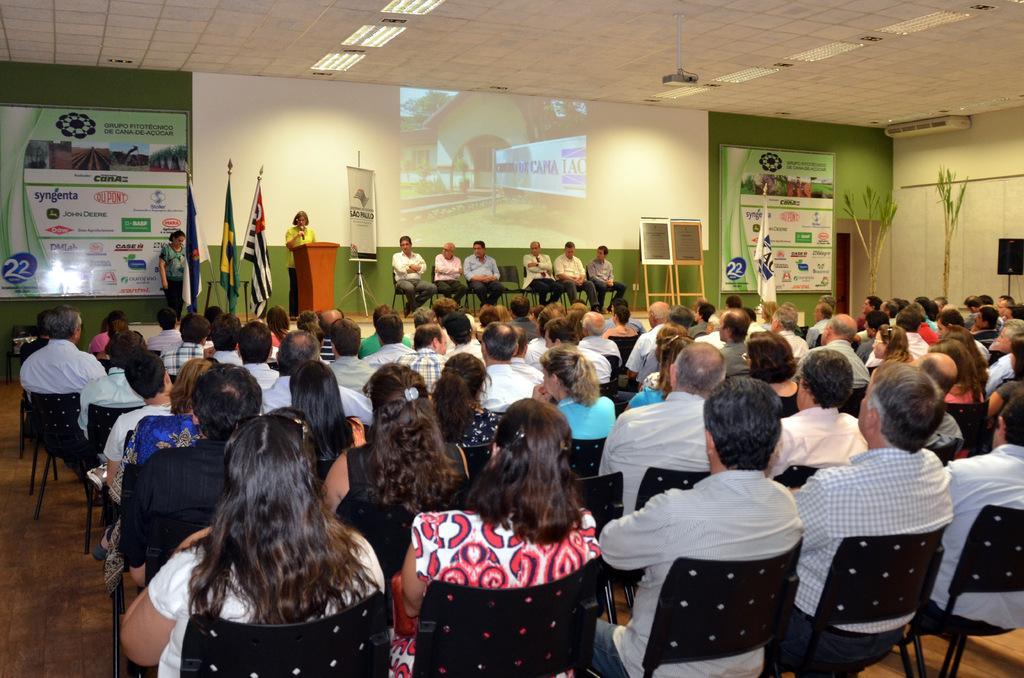How would you summarize this image in a sentence or two? In this image there are group of persons sitting in a room and there are group of persons sitting on the stage and at the left side of the image there is a woman standing behind wooden block holding microphone in her hand and at the background there are some boards. 